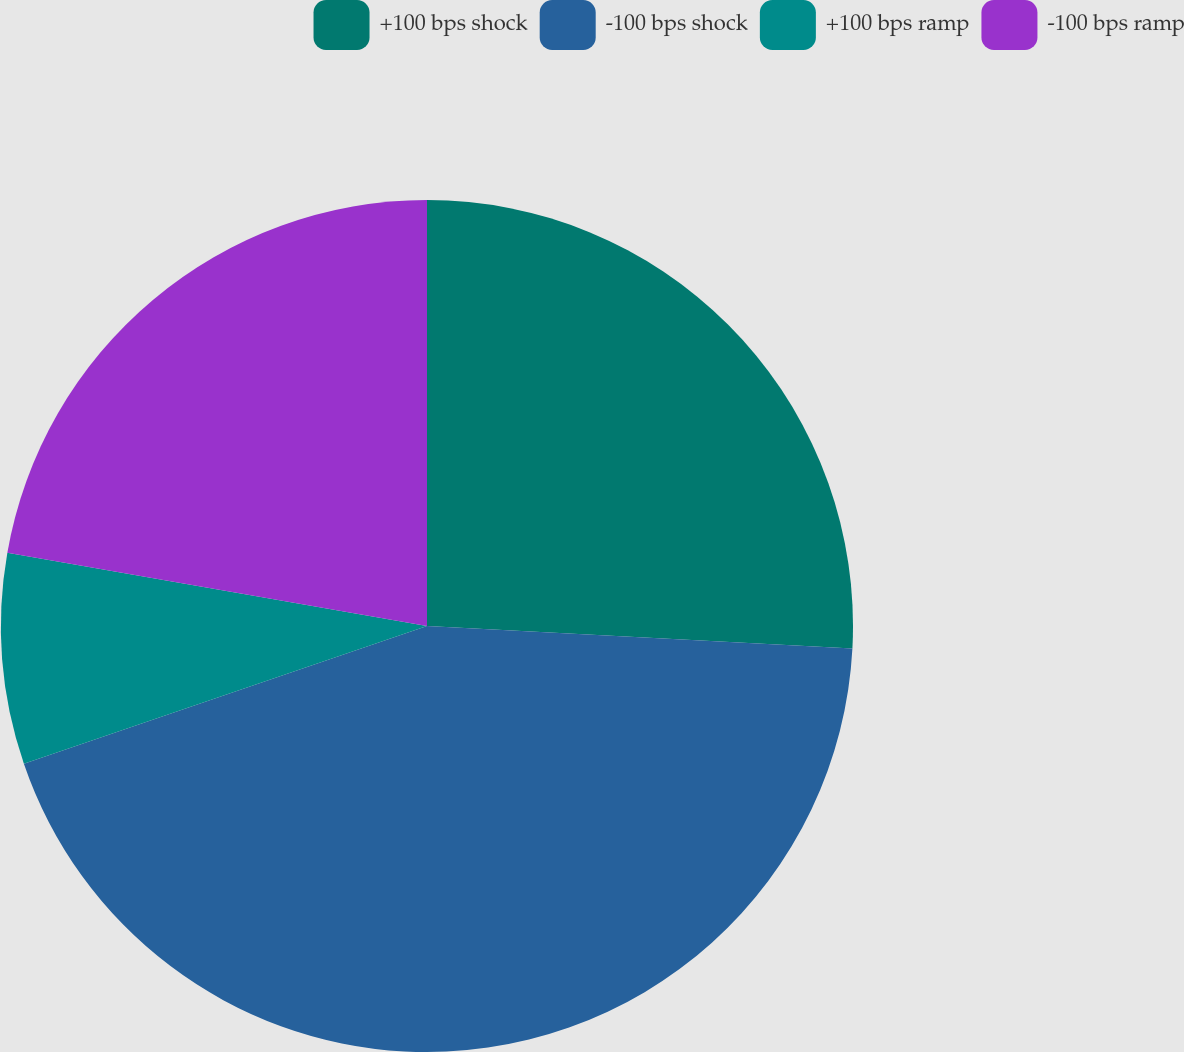Convert chart to OTSL. <chart><loc_0><loc_0><loc_500><loc_500><pie_chart><fcel>+100 bps shock<fcel>-100 bps shock<fcel>+100 bps ramp<fcel>-100 bps ramp<nl><fcel>25.84%<fcel>43.92%<fcel>7.99%<fcel>22.25%<nl></chart> 